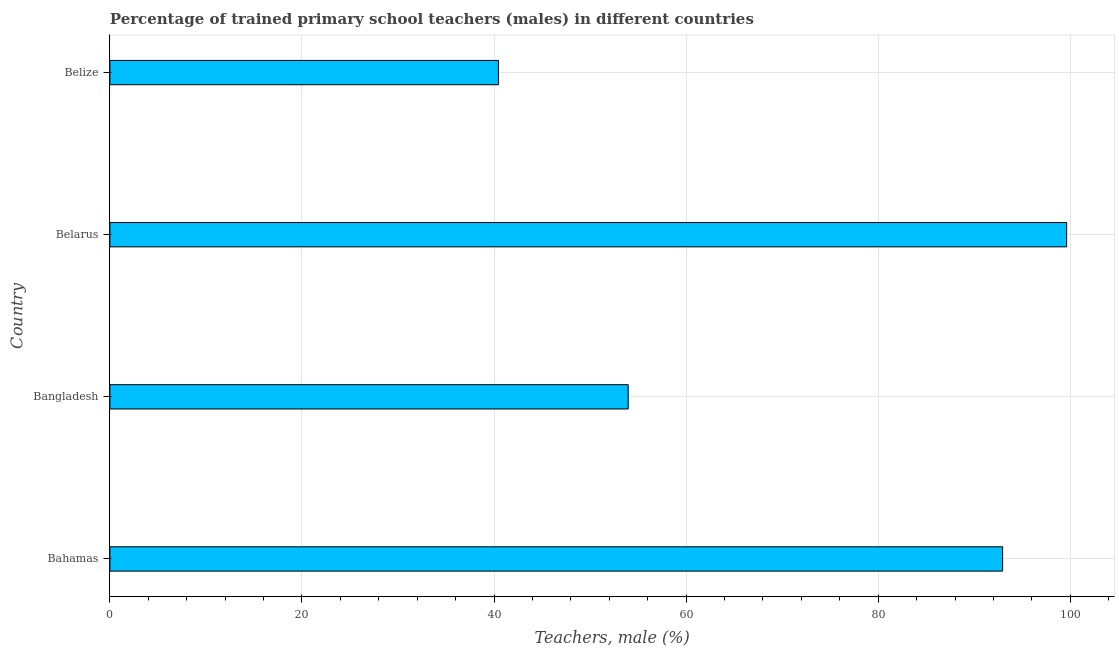Does the graph contain any zero values?
Give a very brief answer. No. What is the title of the graph?
Offer a very short reply. Percentage of trained primary school teachers (males) in different countries. What is the label or title of the X-axis?
Offer a very short reply. Teachers, male (%). What is the percentage of trained male teachers in Belarus?
Ensure brevity in your answer.  99.63. Across all countries, what is the maximum percentage of trained male teachers?
Provide a short and direct response. 99.63. Across all countries, what is the minimum percentage of trained male teachers?
Your response must be concise. 40.46. In which country was the percentage of trained male teachers maximum?
Give a very brief answer. Belarus. In which country was the percentage of trained male teachers minimum?
Keep it short and to the point. Belize. What is the sum of the percentage of trained male teachers?
Offer a terse response. 287.02. What is the difference between the percentage of trained male teachers in Bahamas and Belize?
Offer a terse response. 52.5. What is the average percentage of trained male teachers per country?
Offer a terse response. 71.75. What is the median percentage of trained male teachers?
Keep it short and to the point. 73.46. What is the ratio of the percentage of trained male teachers in Belarus to that in Belize?
Give a very brief answer. 2.46. What is the difference between the highest and the second highest percentage of trained male teachers?
Provide a short and direct response. 6.67. Is the sum of the percentage of trained male teachers in Belarus and Belize greater than the maximum percentage of trained male teachers across all countries?
Provide a short and direct response. Yes. What is the difference between the highest and the lowest percentage of trained male teachers?
Ensure brevity in your answer.  59.17. Are all the bars in the graph horizontal?
Ensure brevity in your answer.  Yes. How many countries are there in the graph?
Your response must be concise. 4. What is the difference between two consecutive major ticks on the X-axis?
Offer a terse response. 20. What is the Teachers, male (%) in Bahamas?
Offer a very short reply. 92.96. What is the Teachers, male (%) in Bangladesh?
Your answer should be very brief. 53.97. What is the Teachers, male (%) of Belarus?
Your answer should be very brief. 99.63. What is the Teachers, male (%) in Belize?
Your answer should be compact. 40.46. What is the difference between the Teachers, male (%) in Bahamas and Bangladesh?
Keep it short and to the point. 38.99. What is the difference between the Teachers, male (%) in Bahamas and Belarus?
Give a very brief answer. -6.67. What is the difference between the Teachers, male (%) in Bahamas and Belize?
Give a very brief answer. 52.5. What is the difference between the Teachers, male (%) in Bangladesh and Belarus?
Your response must be concise. -45.66. What is the difference between the Teachers, male (%) in Bangladesh and Belize?
Give a very brief answer. 13.51. What is the difference between the Teachers, male (%) in Belarus and Belize?
Keep it short and to the point. 59.17. What is the ratio of the Teachers, male (%) in Bahamas to that in Bangladesh?
Give a very brief answer. 1.72. What is the ratio of the Teachers, male (%) in Bahamas to that in Belarus?
Provide a succinct answer. 0.93. What is the ratio of the Teachers, male (%) in Bahamas to that in Belize?
Provide a succinct answer. 2.3. What is the ratio of the Teachers, male (%) in Bangladesh to that in Belarus?
Your answer should be very brief. 0.54. What is the ratio of the Teachers, male (%) in Bangladesh to that in Belize?
Give a very brief answer. 1.33. What is the ratio of the Teachers, male (%) in Belarus to that in Belize?
Offer a terse response. 2.46. 